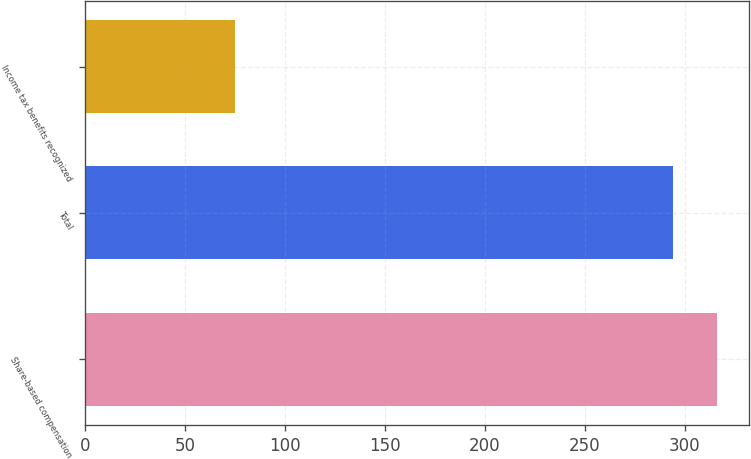Convert chart to OTSL. <chart><loc_0><loc_0><loc_500><loc_500><bar_chart><fcel>Share-based compensation<fcel>Total<fcel>Income tax benefits recognized<nl><fcel>316.2<fcel>294<fcel>75<nl></chart> 